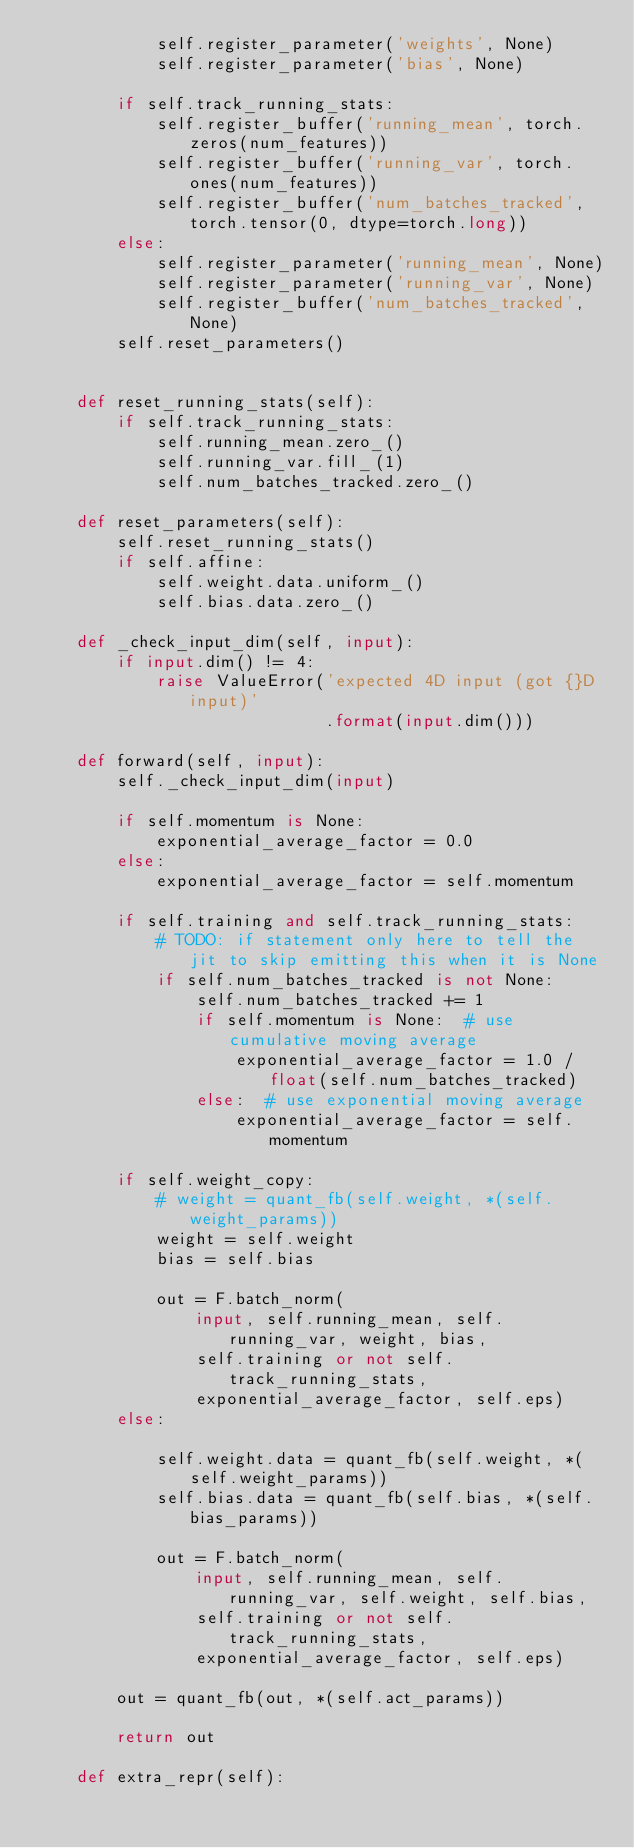Convert code to text. <code><loc_0><loc_0><loc_500><loc_500><_Python_>            self.register_parameter('weights', None)
            self.register_parameter('bias', None)

        if self.track_running_stats:
            self.register_buffer('running_mean', torch.zeros(num_features))
            self.register_buffer('running_var', torch.ones(num_features))
            self.register_buffer('num_batches_tracked', torch.tensor(0, dtype=torch.long))
        else:
            self.register_parameter('running_mean', None)
            self.register_parameter('running_var', None)
            self.register_buffer('num_batches_tracked', None)
        self.reset_parameters()


    def reset_running_stats(self):
        if self.track_running_stats:
            self.running_mean.zero_()
            self.running_var.fill_(1)
            self.num_batches_tracked.zero_()

    def reset_parameters(self):
        self.reset_running_stats()
        if self.affine:
            self.weight.data.uniform_()
            self.bias.data.zero_()

    def _check_input_dim(self, input):
        if input.dim() != 4:
            raise ValueError('expected 4D input (got {}D input)'
                             .format(input.dim()))

    def forward(self, input):
        self._check_input_dim(input)

        if self.momentum is None:
            exponential_average_factor = 0.0
        else:
            exponential_average_factor = self.momentum

        if self.training and self.track_running_stats:
            # TODO: if statement only here to tell the jit to skip emitting this when it is None
            if self.num_batches_tracked is not None:
                self.num_batches_tracked += 1
                if self.momentum is None:  # use cumulative moving average
                    exponential_average_factor = 1.0 / float(self.num_batches_tracked)
                else:  # use exponential moving average
                    exponential_average_factor = self.momentum

        if self.weight_copy:
            # weight = quant_fb(self.weight, *(self.weight_params))
            weight = self.weight
            bias = self.bias 

            out = F.batch_norm(
                input, self.running_mean, self.running_var, weight, bias,
                self.training or not self.track_running_stats,
                exponential_average_factor, self.eps)
        else:

            self.weight.data = quant_fb(self.weight, *(self.weight_params))
            self.bias.data = quant_fb(self.bias, *(self.bias_params))

            out = F.batch_norm(
                input, self.running_mean, self.running_var, self.weight, self.bias,
                self.training or not self.track_running_stats,
                exponential_average_factor, self.eps)

        out = quant_fb(out, *(self.act_params))

        return out

    def extra_repr(self):</code> 